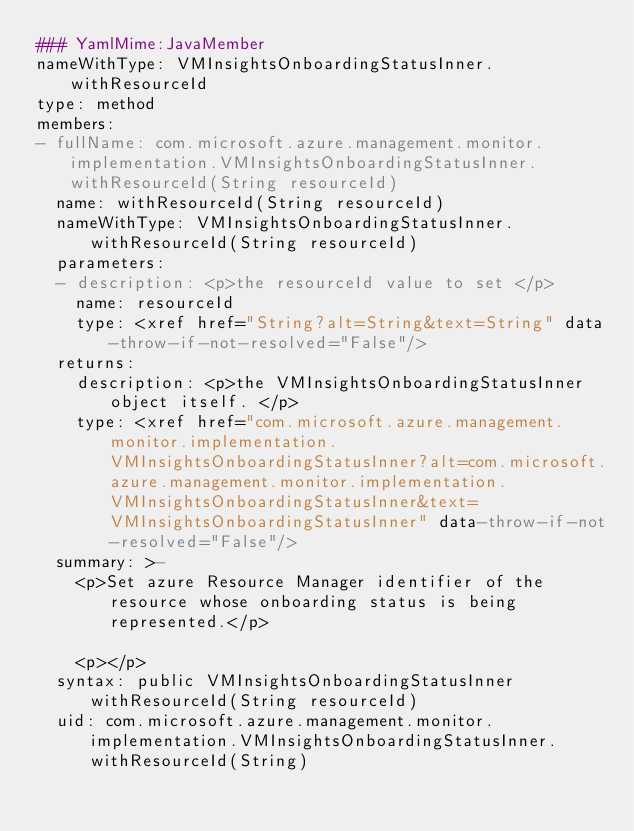Convert code to text. <code><loc_0><loc_0><loc_500><loc_500><_YAML_>### YamlMime:JavaMember
nameWithType: VMInsightsOnboardingStatusInner.withResourceId
type: method
members:
- fullName: com.microsoft.azure.management.monitor.implementation.VMInsightsOnboardingStatusInner.withResourceId(String resourceId)
  name: withResourceId(String resourceId)
  nameWithType: VMInsightsOnboardingStatusInner.withResourceId(String resourceId)
  parameters:
  - description: <p>the resourceId value to set </p>
    name: resourceId
    type: <xref href="String?alt=String&text=String" data-throw-if-not-resolved="False"/>
  returns:
    description: <p>the VMInsightsOnboardingStatusInner object itself. </p>
    type: <xref href="com.microsoft.azure.management.monitor.implementation.VMInsightsOnboardingStatusInner?alt=com.microsoft.azure.management.monitor.implementation.VMInsightsOnboardingStatusInner&text=VMInsightsOnboardingStatusInner" data-throw-if-not-resolved="False"/>
  summary: >-
    <p>Set azure Resource Manager identifier of the resource whose onboarding status is being represented.</p>

    <p></p>
  syntax: public VMInsightsOnboardingStatusInner withResourceId(String resourceId)
  uid: com.microsoft.azure.management.monitor.implementation.VMInsightsOnboardingStatusInner.withResourceId(String)</code> 